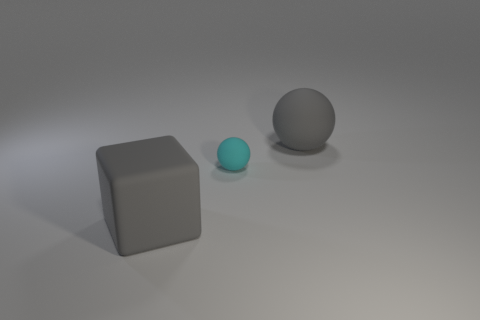Add 1 matte things. How many objects exist? 4 Subtract all balls. How many objects are left? 1 Add 3 tiny rubber objects. How many tiny rubber objects exist? 4 Subtract 0 blue cylinders. How many objects are left? 3 Subtract all big objects. Subtract all cubes. How many objects are left? 0 Add 3 cyan matte spheres. How many cyan matte spheres are left? 4 